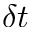<formula> <loc_0><loc_0><loc_500><loc_500>\delta t</formula> 